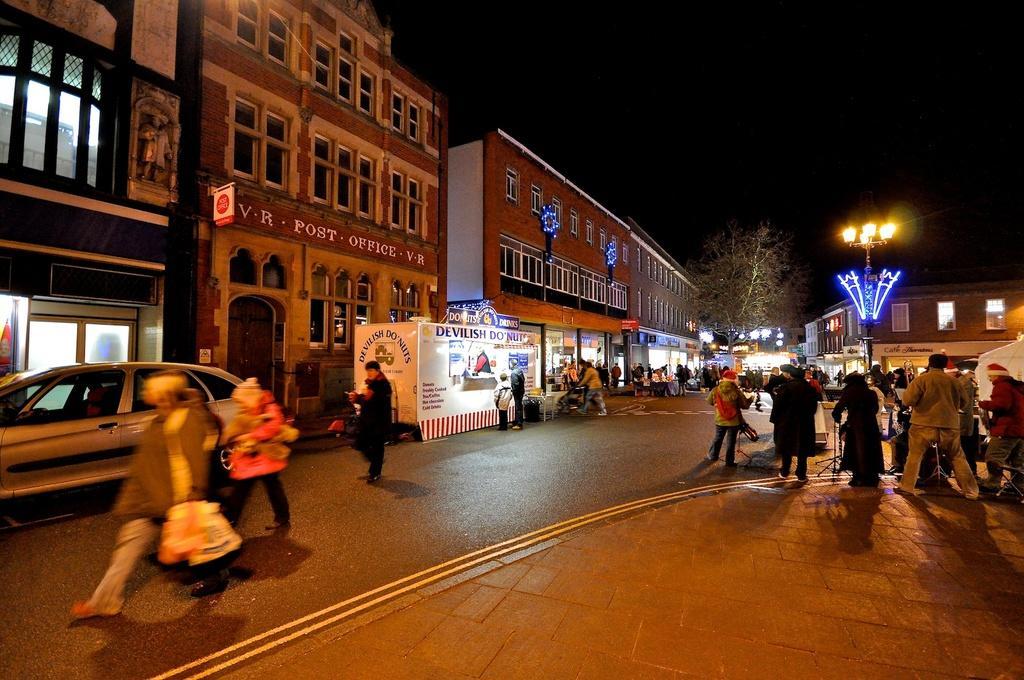Describe this image in one or two sentences. This is the picture of a city. In the foreground there are group of people standing on the footpath. On the left side of the image there are group of people walking on the road and there is a vehicle on the road and there are buildings and there are hoardings on the buildings. At the back there is a tree and building. There is a street light on the footpath. At the top there is sky. At the bottom there is a road. 